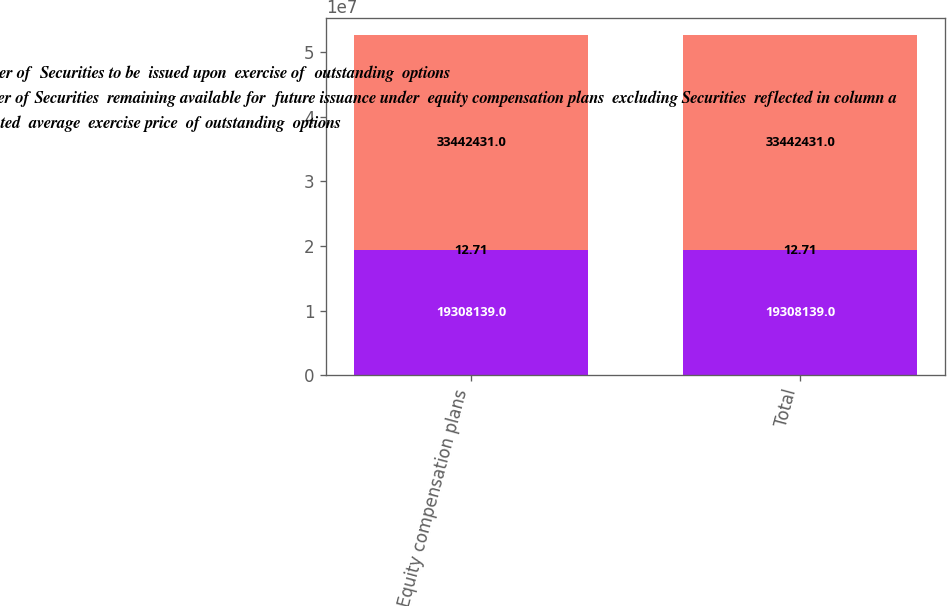Convert chart. <chart><loc_0><loc_0><loc_500><loc_500><stacked_bar_chart><ecel><fcel>Equity compensation plans<fcel>Total<nl><fcel>a Number of  Securities to be  issued upon  exercise of  outstanding  options<fcel>1.93081e+07<fcel>1.93081e+07<nl><fcel>c Number of Securities  remaining available for  future issuance under  equity compensation plans  excluding Securities  reflected in column a<fcel>12.71<fcel>12.71<nl><fcel>b Weighted  average  exercise price  of outstanding  options<fcel>3.34424e+07<fcel>3.34424e+07<nl></chart> 